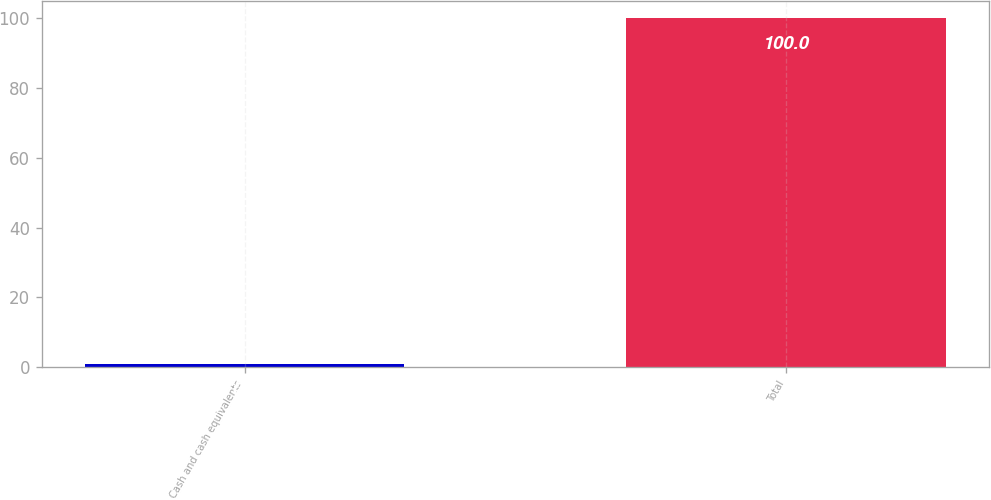Convert chart. <chart><loc_0><loc_0><loc_500><loc_500><bar_chart><fcel>Cash and cash equivalents<fcel>Total<nl><fcel>0.9<fcel>100<nl></chart> 